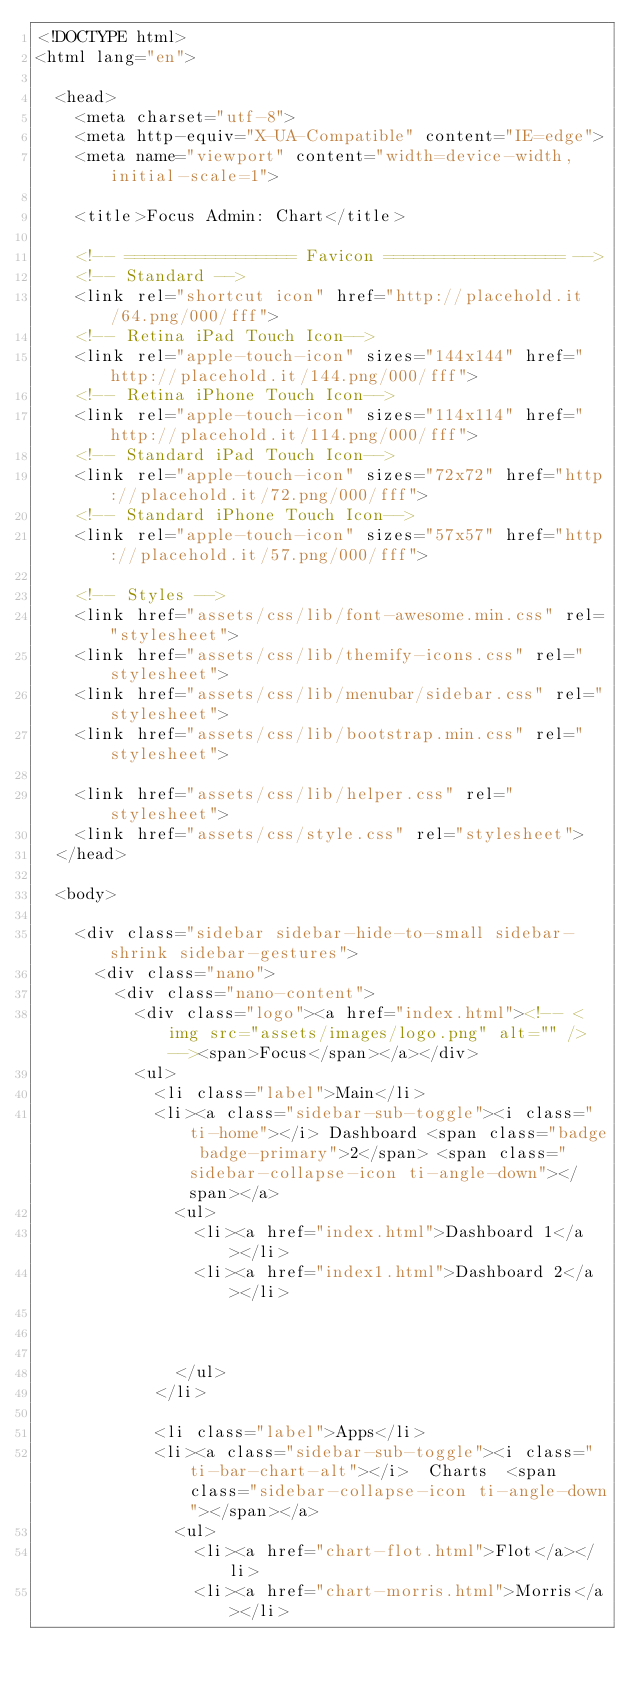<code> <loc_0><loc_0><loc_500><loc_500><_HTML_><!DOCTYPE html>
<html lang="en">

  <head>
    <meta charset="utf-8">
    <meta http-equiv="X-UA-Compatible" content="IE=edge">
    <meta name="viewport" content="width=device-width, initial-scale=1">

    <title>Focus Admin: Chart</title>

    <!-- ================= Favicon ================== -->
    <!-- Standard -->
    <link rel="shortcut icon" href="http://placehold.it/64.png/000/fff">
    <!-- Retina iPad Touch Icon-->
    <link rel="apple-touch-icon" sizes="144x144" href="http://placehold.it/144.png/000/fff">
    <!-- Retina iPhone Touch Icon-->
    <link rel="apple-touch-icon" sizes="114x114" href="http://placehold.it/114.png/000/fff">
    <!-- Standard iPad Touch Icon-->
    <link rel="apple-touch-icon" sizes="72x72" href="http://placehold.it/72.png/000/fff">
    <!-- Standard iPhone Touch Icon-->
    <link rel="apple-touch-icon" sizes="57x57" href="http://placehold.it/57.png/000/fff">

    <!-- Styles -->
    <link href="assets/css/lib/font-awesome.min.css" rel="stylesheet">
    <link href="assets/css/lib/themify-icons.css" rel="stylesheet">
    <link href="assets/css/lib/menubar/sidebar.css" rel="stylesheet">
    <link href="assets/css/lib/bootstrap.min.css" rel="stylesheet">
    
    <link href="assets/css/lib/helper.css" rel="stylesheet">
    <link href="assets/css/style.css" rel="stylesheet">
  </head>

  <body>

    <div class="sidebar sidebar-hide-to-small sidebar-shrink sidebar-gestures">
      <div class="nano">
        <div class="nano-content">
          <div class="logo"><a href="index.html"><!-- <img src="assets/images/logo.png" alt="" /> --><span>Focus</span></a></div>
          <ul>
            <li class="label">Main</li>
            <li><a class="sidebar-sub-toggle"><i class="ti-home"></i> Dashboard <span class="badge badge-primary">2</span> <span class="sidebar-collapse-icon ti-angle-down"></span></a>
              <ul>
                <li><a href="index.html">Dashboard 1</a></li>
                <li><a href="index1.html">Dashboard 2</a></li>
                
                
                
              </ul>
            </li>

            <li class="label">Apps</li>
            <li><a class="sidebar-sub-toggle"><i class="ti-bar-chart-alt"></i>  Charts  <span class="sidebar-collapse-icon ti-angle-down"></span></a>
              <ul>
                <li><a href="chart-flot.html">Flot</a></li>
                <li><a href="chart-morris.html">Morris</a></li></code> 